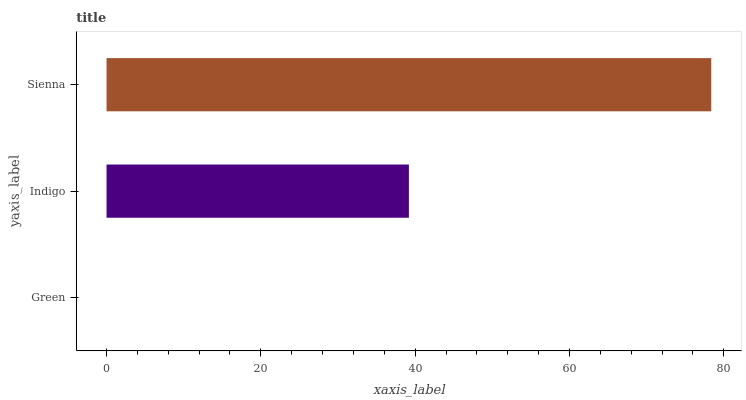Is Green the minimum?
Answer yes or no. Yes. Is Sienna the maximum?
Answer yes or no. Yes. Is Indigo the minimum?
Answer yes or no. No. Is Indigo the maximum?
Answer yes or no. No. Is Indigo greater than Green?
Answer yes or no. Yes. Is Green less than Indigo?
Answer yes or no. Yes. Is Green greater than Indigo?
Answer yes or no. No. Is Indigo less than Green?
Answer yes or no. No. Is Indigo the high median?
Answer yes or no. Yes. Is Indigo the low median?
Answer yes or no. Yes. Is Green the high median?
Answer yes or no. No. Is Sienna the low median?
Answer yes or no. No. 